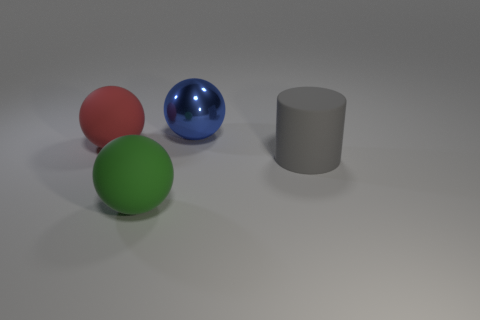Subtract all metal balls. How many balls are left? 2 Add 2 big red matte blocks. How many objects exist? 6 Subtract 1 spheres. How many spheres are left? 2 Subtract all cylinders. How many objects are left? 3 Subtract all red balls. Subtract all green cylinders. How many balls are left? 2 Subtract all large cyan rubber blocks. Subtract all big cylinders. How many objects are left? 3 Add 4 blue things. How many blue things are left? 5 Add 3 large blue metal balls. How many large blue metal balls exist? 4 Subtract 0 purple spheres. How many objects are left? 4 